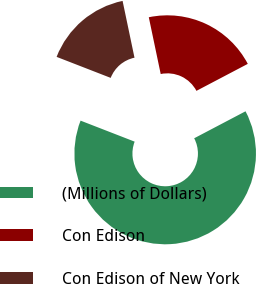Convert chart. <chart><loc_0><loc_0><loc_500><loc_500><pie_chart><fcel>(Millions of Dollars)<fcel>Con Edison<fcel>Con Edison of New York<nl><fcel>63.6%<fcel>20.59%<fcel>15.81%<nl></chart> 